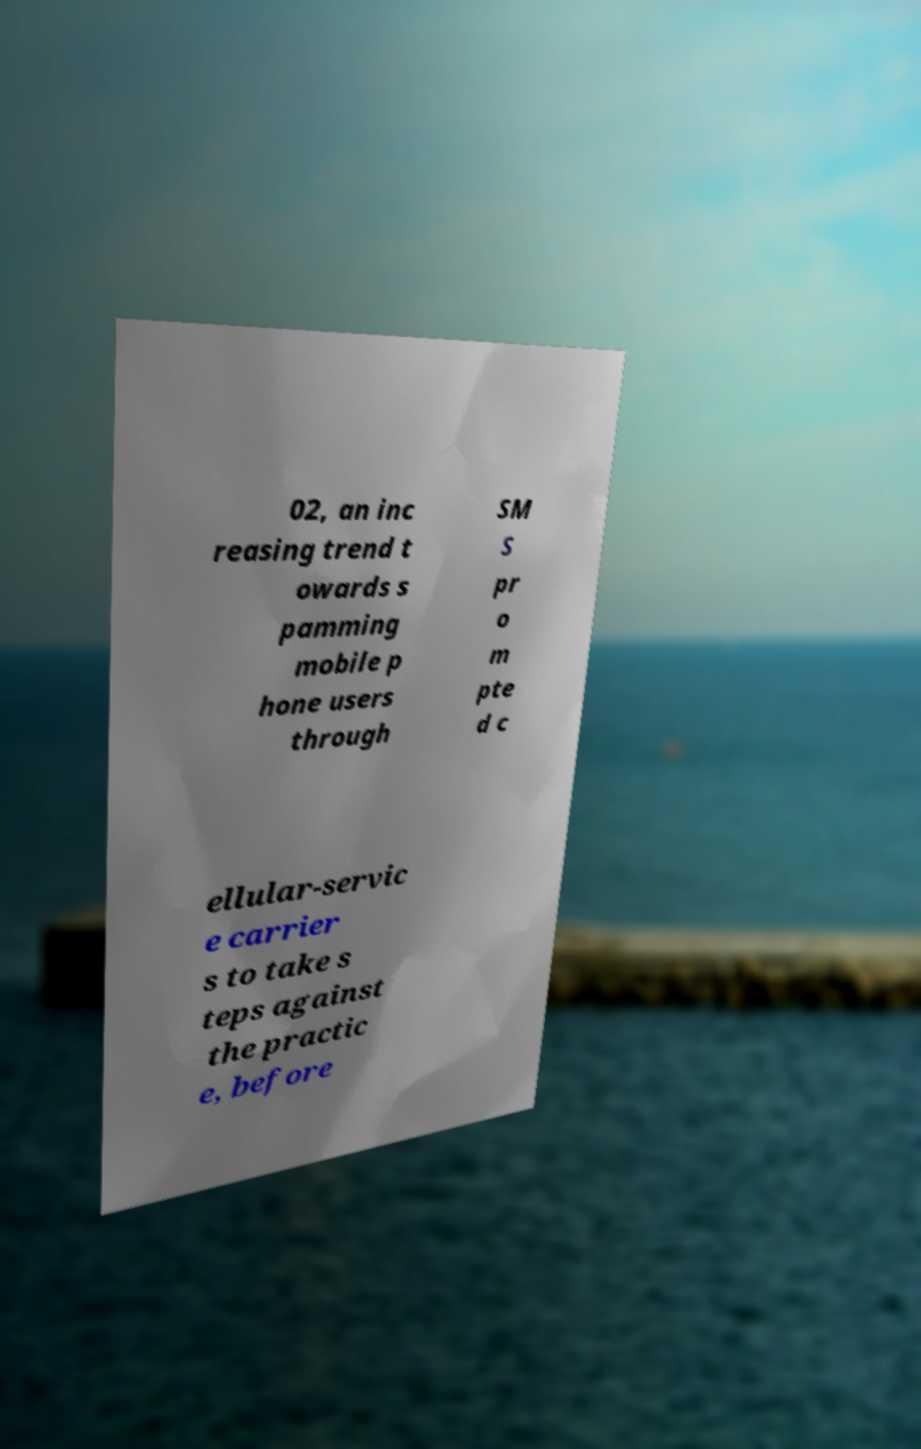Could you assist in decoding the text presented in this image and type it out clearly? 02, an inc reasing trend t owards s pamming mobile p hone users through SM S pr o m pte d c ellular-servic e carrier s to take s teps against the practic e, before 